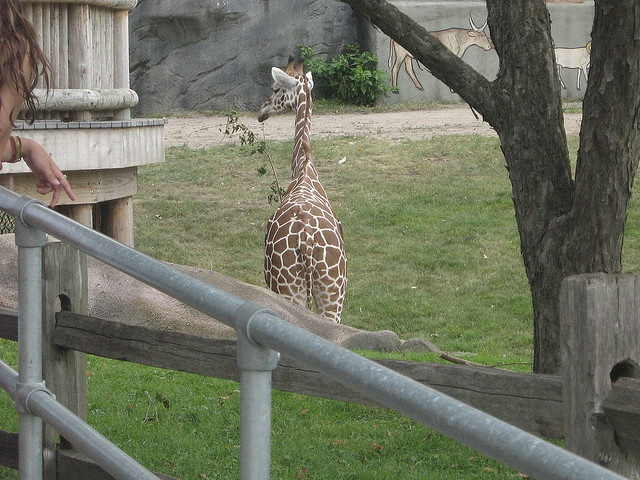Describe the objects in this image and their specific colors. I can see giraffe in black, gray, darkgray, and lightgray tones and people in black, gray, and darkgray tones in this image. 